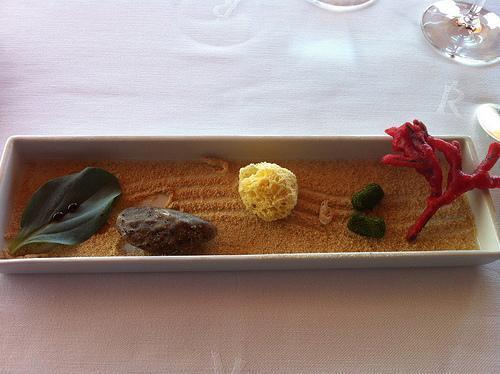How many leaves are shown?
Give a very brief answer. 1. 